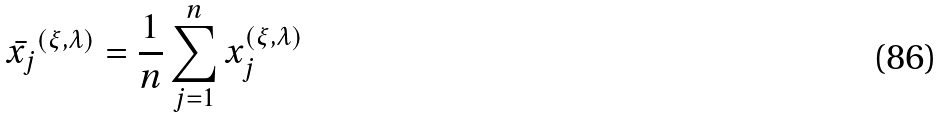Convert formula to latex. <formula><loc_0><loc_0><loc_500><loc_500>\bar { x _ { j } } ^ { ( \xi , \lambda ) } = \frac { 1 } { n } \sum _ { j = 1 } ^ { n } x _ { j } ^ { ( \xi , \lambda ) }</formula> 